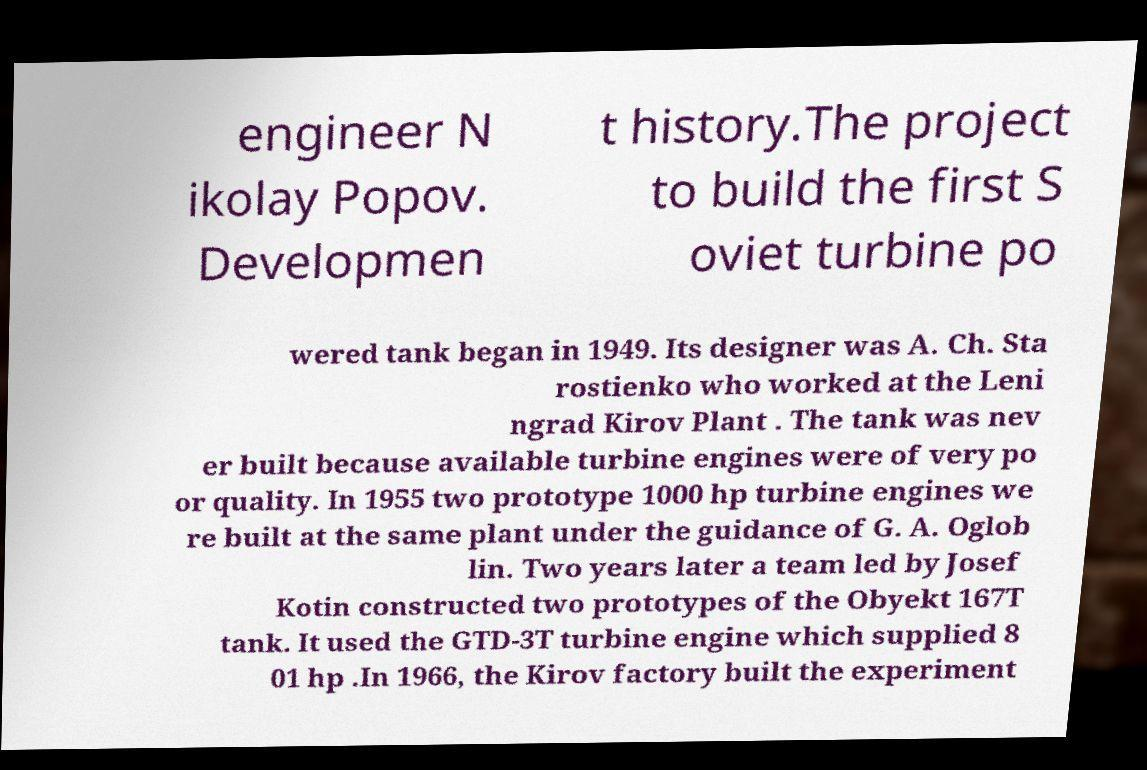Please identify and transcribe the text found in this image. engineer N ikolay Popov. Developmen t history.The project to build the first S oviet turbine po wered tank began in 1949. Its designer was A. Ch. Sta rostienko who worked at the Leni ngrad Kirov Plant . The tank was nev er built because available turbine engines were of very po or quality. In 1955 two prototype 1000 hp turbine engines we re built at the same plant under the guidance of G. A. Oglob lin. Two years later a team led by Josef Kotin constructed two prototypes of the Obyekt 167T tank. It used the GTD-3T turbine engine which supplied 8 01 hp .In 1966, the Kirov factory built the experiment 